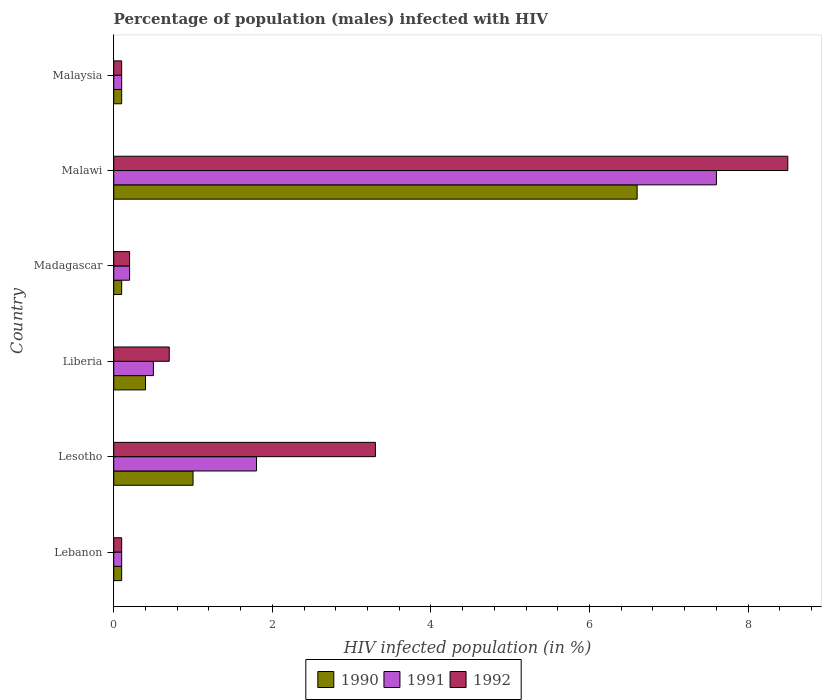Are the number of bars on each tick of the Y-axis equal?
Ensure brevity in your answer.  Yes. How many bars are there on the 5th tick from the top?
Provide a succinct answer. 3. What is the label of the 1st group of bars from the top?
Ensure brevity in your answer.  Malaysia. In how many cases, is the number of bars for a given country not equal to the number of legend labels?
Offer a terse response. 0. Across all countries, what is the minimum percentage of HIV infected male population in 1990?
Ensure brevity in your answer.  0.1. In which country was the percentage of HIV infected male population in 1991 maximum?
Provide a succinct answer. Malawi. In which country was the percentage of HIV infected male population in 1991 minimum?
Offer a terse response. Lebanon. What is the average percentage of HIV infected male population in 1992 per country?
Your answer should be very brief. 2.15. What is the difference between the percentage of HIV infected male population in 1992 and percentage of HIV infected male population in 1991 in Lesotho?
Make the answer very short. 1.5. In how many countries, is the percentage of HIV infected male population in 1992 greater than 1.2000000000000002 %?
Provide a succinct answer. 2. What is the difference between the highest and the lowest percentage of HIV infected male population in 1992?
Keep it short and to the point. 8.4. In how many countries, is the percentage of HIV infected male population in 1991 greater than the average percentage of HIV infected male population in 1991 taken over all countries?
Provide a short and direct response. 2. What does the 1st bar from the top in Lebanon represents?
Provide a succinct answer. 1992. What does the 3rd bar from the bottom in Lesotho represents?
Provide a short and direct response. 1992. Is it the case that in every country, the sum of the percentage of HIV infected male population in 1992 and percentage of HIV infected male population in 1991 is greater than the percentage of HIV infected male population in 1990?
Offer a very short reply. Yes. How many countries are there in the graph?
Ensure brevity in your answer.  6. Does the graph contain any zero values?
Provide a succinct answer. No. Does the graph contain grids?
Your answer should be compact. No. How many legend labels are there?
Provide a short and direct response. 3. How are the legend labels stacked?
Provide a short and direct response. Horizontal. What is the title of the graph?
Make the answer very short. Percentage of population (males) infected with HIV. Does "2001" appear as one of the legend labels in the graph?
Keep it short and to the point. No. What is the label or title of the X-axis?
Make the answer very short. HIV infected population (in %). What is the label or title of the Y-axis?
Offer a very short reply. Country. What is the HIV infected population (in %) of 1992 in Lebanon?
Give a very brief answer. 0.1. What is the HIV infected population (in %) of 1991 in Lesotho?
Offer a very short reply. 1.8. What is the HIV infected population (in %) in 1992 in Liberia?
Keep it short and to the point. 0.7. What is the HIV infected population (in %) of 1990 in Madagascar?
Ensure brevity in your answer.  0.1. What is the HIV infected population (in %) in 1992 in Madagascar?
Your response must be concise. 0.2. What is the HIV infected population (in %) of 1992 in Malawi?
Provide a short and direct response. 8.5. What is the HIV infected population (in %) in 1991 in Malaysia?
Ensure brevity in your answer.  0.1. Across all countries, what is the maximum HIV infected population (in %) of 1990?
Ensure brevity in your answer.  6.6. Across all countries, what is the minimum HIV infected population (in %) in 1991?
Offer a terse response. 0.1. What is the total HIV infected population (in %) in 1991 in the graph?
Your response must be concise. 10.3. What is the total HIV infected population (in %) of 1992 in the graph?
Keep it short and to the point. 12.9. What is the difference between the HIV infected population (in %) in 1990 in Lebanon and that in Lesotho?
Your response must be concise. -0.9. What is the difference between the HIV infected population (in %) in 1992 in Lebanon and that in Lesotho?
Your response must be concise. -3.2. What is the difference between the HIV infected population (in %) of 1991 in Lebanon and that in Liberia?
Your response must be concise. -0.4. What is the difference between the HIV infected population (in %) in 1992 in Lebanon and that in Liberia?
Keep it short and to the point. -0.6. What is the difference between the HIV infected population (in %) of 1991 in Lebanon and that in Madagascar?
Your answer should be very brief. -0.1. What is the difference between the HIV infected population (in %) in 1990 in Lebanon and that in Malaysia?
Offer a terse response. 0. What is the difference between the HIV infected population (in %) in 1991 in Lebanon and that in Malaysia?
Your answer should be compact. 0. What is the difference between the HIV infected population (in %) in 1992 in Lebanon and that in Malaysia?
Ensure brevity in your answer.  0. What is the difference between the HIV infected population (in %) of 1991 in Lesotho and that in Liberia?
Offer a terse response. 1.3. What is the difference between the HIV infected population (in %) of 1991 in Lesotho and that in Madagascar?
Provide a short and direct response. 1.6. What is the difference between the HIV infected population (in %) of 1991 in Lesotho and that in Malawi?
Offer a very short reply. -5.8. What is the difference between the HIV infected population (in %) in 1990 in Lesotho and that in Malaysia?
Ensure brevity in your answer.  0.9. What is the difference between the HIV infected population (in %) of 1991 in Lesotho and that in Malaysia?
Provide a short and direct response. 1.7. What is the difference between the HIV infected population (in %) of 1992 in Liberia and that in Madagascar?
Offer a very short reply. 0.5. What is the difference between the HIV infected population (in %) of 1990 in Liberia and that in Malawi?
Your response must be concise. -6.2. What is the difference between the HIV infected population (in %) in 1991 in Liberia and that in Malawi?
Provide a short and direct response. -7.1. What is the difference between the HIV infected population (in %) of 1992 in Liberia and that in Malawi?
Give a very brief answer. -7.8. What is the difference between the HIV infected population (in %) in 1991 in Liberia and that in Malaysia?
Ensure brevity in your answer.  0.4. What is the difference between the HIV infected population (in %) of 1992 in Liberia and that in Malaysia?
Make the answer very short. 0.6. What is the difference between the HIV infected population (in %) of 1990 in Madagascar and that in Malawi?
Offer a terse response. -6.5. What is the difference between the HIV infected population (in %) of 1990 in Madagascar and that in Malaysia?
Ensure brevity in your answer.  0. What is the difference between the HIV infected population (in %) in 1992 in Madagascar and that in Malaysia?
Give a very brief answer. 0.1. What is the difference between the HIV infected population (in %) of 1991 in Lebanon and the HIV infected population (in %) of 1992 in Liberia?
Ensure brevity in your answer.  -0.6. What is the difference between the HIV infected population (in %) in 1990 in Lebanon and the HIV infected population (in %) in 1991 in Madagascar?
Keep it short and to the point. -0.1. What is the difference between the HIV infected population (in %) in 1990 in Lebanon and the HIV infected population (in %) in 1992 in Madagascar?
Offer a very short reply. -0.1. What is the difference between the HIV infected population (in %) in 1990 in Lebanon and the HIV infected population (in %) in 1992 in Malawi?
Provide a short and direct response. -8.4. What is the difference between the HIV infected population (in %) in 1991 in Lebanon and the HIV infected population (in %) in 1992 in Malaysia?
Make the answer very short. 0. What is the difference between the HIV infected population (in %) in 1991 in Lesotho and the HIV infected population (in %) in 1992 in Liberia?
Your answer should be very brief. 1.1. What is the difference between the HIV infected population (in %) of 1990 in Lesotho and the HIV infected population (in %) of 1992 in Madagascar?
Make the answer very short. 0.8. What is the difference between the HIV infected population (in %) of 1991 in Lesotho and the HIV infected population (in %) of 1992 in Madagascar?
Provide a short and direct response. 1.6. What is the difference between the HIV infected population (in %) of 1990 in Lesotho and the HIV infected population (in %) of 1991 in Malawi?
Your response must be concise. -6.6. What is the difference between the HIV infected population (in %) of 1990 in Lesotho and the HIV infected population (in %) of 1992 in Malaysia?
Your answer should be very brief. 0.9. What is the difference between the HIV infected population (in %) in 1991 in Lesotho and the HIV infected population (in %) in 1992 in Malaysia?
Make the answer very short. 1.7. What is the difference between the HIV infected population (in %) of 1991 in Liberia and the HIV infected population (in %) of 1992 in Madagascar?
Keep it short and to the point. 0.3. What is the difference between the HIV infected population (in %) in 1991 in Liberia and the HIV infected population (in %) in 1992 in Malawi?
Provide a short and direct response. -8. What is the difference between the HIV infected population (in %) of 1991 in Liberia and the HIV infected population (in %) of 1992 in Malaysia?
Keep it short and to the point. 0.4. What is the difference between the HIV infected population (in %) in 1990 in Madagascar and the HIV infected population (in %) in 1992 in Malawi?
Provide a succinct answer. -8.4. What is the difference between the HIV infected population (in %) of 1990 in Madagascar and the HIV infected population (in %) of 1992 in Malaysia?
Ensure brevity in your answer.  0. What is the difference between the HIV infected population (in %) in 1991 in Malawi and the HIV infected population (in %) in 1992 in Malaysia?
Provide a short and direct response. 7.5. What is the average HIV infected population (in %) in 1990 per country?
Provide a short and direct response. 1.38. What is the average HIV infected population (in %) of 1991 per country?
Give a very brief answer. 1.72. What is the average HIV infected population (in %) of 1992 per country?
Your response must be concise. 2.15. What is the difference between the HIV infected population (in %) of 1990 and HIV infected population (in %) of 1991 in Lesotho?
Provide a succinct answer. -0.8. What is the difference between the HIV infected population (in %) of 1990 and HIV infected population (in %) of 1992 in Lesotho?
Offer a very short reply. -2.3. What is the difference between the HIV infected population (in %) in 1991 and HIV infected population (in %) in 1992 in Liberia?
Make the answer very short. -0.2. What is the difference between the HIV infected population (in %) of 1991 and HIV infected population (in %) of 1992 in Madagascar?
Keep it short and to the point. 0. What is the difference between the HIV infected population (in %) of 1990 and HIV infected population (in %) of 1991 in Malawi?
Ensure brevity in your answer.  -1. What is the difference between the HIV infected population (in %) of 1990 and HIV infected population (in %) of 1991 in Malaysia?
Keep it short and to the point. 0. What is the difference between the HIV infected population (in %) of 1990 and HIV infected population (in %) of 1992 in Malaysia?
Offer a very short reply. 0. What is the difference between the HIV infected population (in %) in 1991 and HIV infected population (in %) in 1992 in Malaysia?
Provide a succinct answer. 0. What is the ratio of the HIV infected population (in %) in 1991 in Lebanon to that in Lesotho?
Ensure brevity in your answer.  0.06. What is the ratio of the HIV infected population (in %) in 1992 in Lebanon to that in Lesotho?
Provide a short and direct response. 0.03. What is the ratio of the HIV infected population (in %) in 1990 in Lebanon to that in Liberia?
Make the answer very short. 0.25. What is the ratio of the HIV infected population (in %) of 1991 in Lebanon to that in Liberia?
Ensure brevity in your answer.  0.2. What is the ratio of the HIV infected population (in %) in 1992 in Lebanon to that in Liberia?
Your answer should be compact. 0.14. What is the ratio of the HIV infected population (in %) of 1990 in Lebanon to that in Malawi?
Offer a terse response. 0.02. What is the ratio of the HIV infected population (in %) of 1991 in Lebanon to that in Malawi?
Provide a succinct answer. 0.01. What is the ratio of the HIV infected population (in %) of 1992 in Lebanon to that in Malawi?
Ensure brevity in your answer.  0.01. What is the ratio of the HIV infected population (in %) of 1991 in Lebanon to that in Malaysia?
Your answer should be very brief. 1. What is the ratio of the HIV infected population (in %) of 1992 in Lesotho to that in Liberia?
Provide a succinct answer. 4.71. What is the ratio of the HIV infected population (in %) of 1990 in Lesotho to that in Madagascar?
Keep it short and to the point. 10. What is the ratio of the HIV infected population (in %) in 1991 in Lesotho to that in Madagascar?
Offer a terse response. 9. What is the ratio of the HIV infected population (in %) in 1992 in Lesotho to that in Madagascar?
Give a very brief answer. 16.5. What is the ratio of the HIV infected population (in %) of 1990 in Lesotho to that in Malawi?
Provide a short and direct response. 0.15. What is the ratio of the HIV infected population (in %) in 1991 in Lesotho to that in Malawi?
Ensure brevity in your answer.  0.24. What is the ratio of the HIV infected population (in %) of 1992 in Lesotho to that in Malawi?
Your answer should be very brief. 0.39. What is the ratio of the HIV infected population (in %) of 1991 in Lesotho to that in Malaysia?
Your answer should be compact. 18. What is the ratio of the HIV infected population (in %) of 1991 in Liberia to that in Madagascar?
Offer a very short reply. 2.5. What is the ratio of the HIV infected population (in %) in 1990 in Liberia to that in Malawi?
Make the answer very short. 0.06. What is the ratio of the HIV infected population (in %) of 1991 in Liberia to that in Malawi?
Provide a succinct answer. 0.07. What is the ratio of the HIV infected population (in %) of 1992 in Liberia to that in Malawi?
Offer a very short reply. 0.08. What is the ratio of the HIV infected population (in %) in 1990 in Madagascar to that in Malawi?
Provide a short and direct response. 0.02. What is the ratio of the HIV infected population (in %) of 1991 in Madagascar to that in Malawi?
Provide a short and direct response. 0.03. What is the ratio of the HIV infected population (in %) of 1992 in Madagascar to that in Malawi?
Ensure brevity in your answer.  0.02. What is the ratio of the HIV infected population (in %) of 1991 in Madagascar to that in Malaysia?
Make the answer very short. 2. What is the ratio of the HIV infected population (in %) of 1991 in Malawi to that in Malaysia?
Keep it short and to the point. 76. What is the ratio of the HIV infected population (in %) in 1992 in Malawi to that in Malaysia?
Your answer should be very brief. 85. What is the difference between the highest and the second highest HIV infected population (in %) of 1990?
Provide a succinct answer. 5.6. What is the difference between the highest and the second highest HIV infected population (in %) of 1992?
Provide a succinct answer. 5.2. 